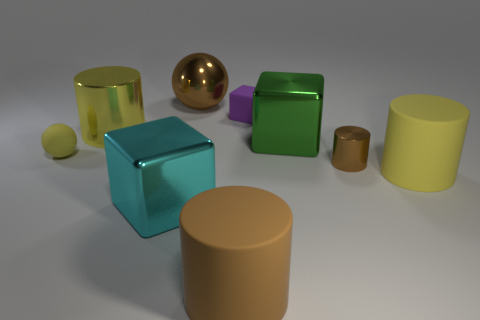There is a metallic cylinder that is to the right of the tiny purple matte block; are there any small cylinders right of it?
Offer a terse response. No. How many other things are there of the same shape as the purple thing?
Your response must be concise. 2. Is the large yellow rubber object the same shape as the big yellow metal thing?
Your answer should be very brief. Yes. What color is the big thing that is in front of the big yellow metallic cylinder and behind the small yellow ball?
Ensure brevity in your answer.  Green. The matte cylinder that is the same color as the big sphere is what size?
Your answer should be compact. Large. What number of large things are either cyan cubes or brown shiny blocks?
Give a very brief answer. 1. Is there anything else of the same color as the rubber cube?
Your response must be concise. No. There is a block behind the large object to the left of the large metallic cube that is left of the purple rubber cube; what is it made of?
Give a very brief answer. Rubber. How many matte things are tiny blue blocks or tiny purple objects?
Provide a short and direct response. 1. How many brown objects are matte things or big metallic spheres?
Your answer should be very brief. 2. 